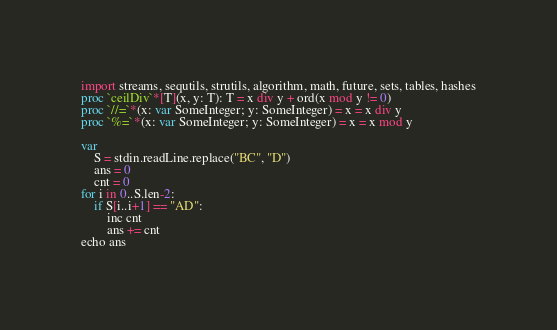Convert code to text. <code><loc_0><loc_0><loc_500><loc_500><_Nim_>import streams, sequtils, strutils, algorithm, math, future, sets, tables, hashes
proc `ceilDiv`*[T](x, y: T): T = x div y + ord(x mod y != 0)
proc `//=`*(x: var SomeInteger; y: SomeInteger) = x = x div y
proc `%=`*(x: var SomeInteger; y: SomeInteger) = x = x mod y

var
    S = stdin.readLine.replace("BC", "D")
    ans = 0
    cnt = 0
for i in 0..S.len-2:
    if S[i..i+1] == "AD":
        inc cnt
        ans += cnt
echo ans </code> 